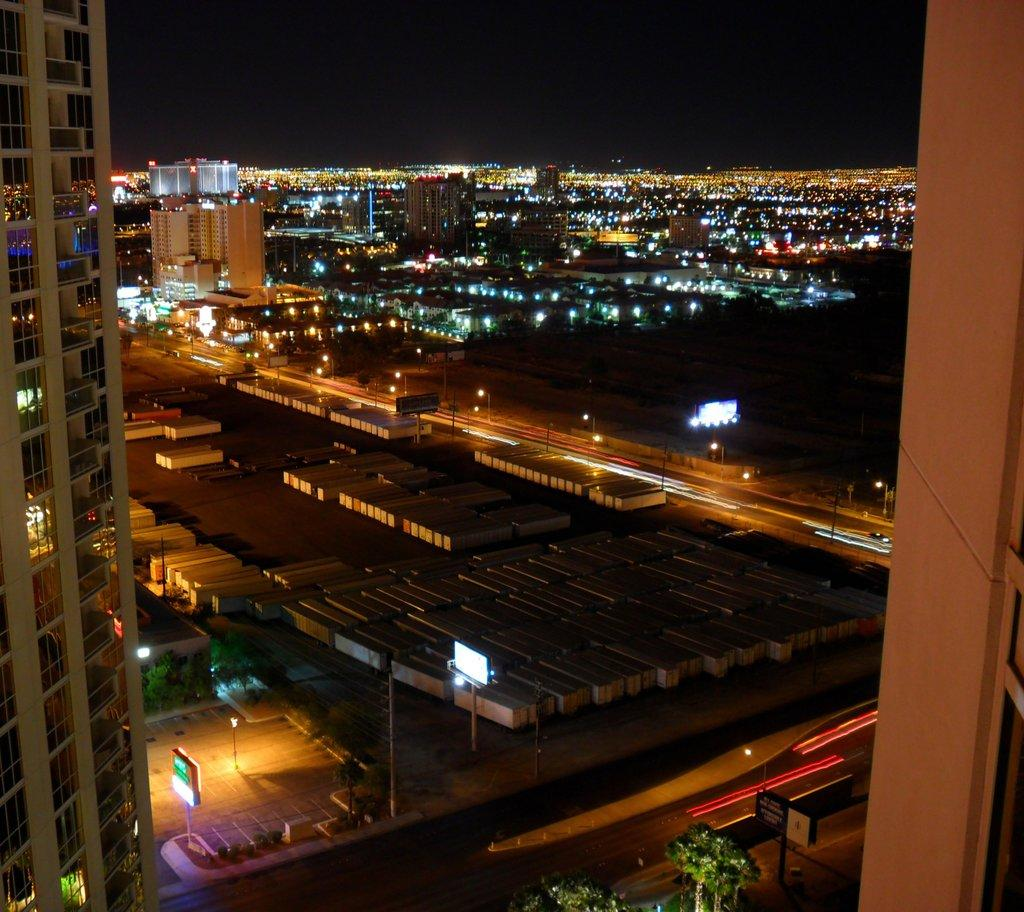What type of structures can be seen in the image? There are buildings in the image. Can you describe any other elements in the image besides the buildings? Yes, there are lights visible in the image. What type of island is featured in the image? There is no island present in the image; it features buildings and lights. What type of attraction can be seen in the image? The image does not depict a specific attraction; it simply shows buildings and lights. 